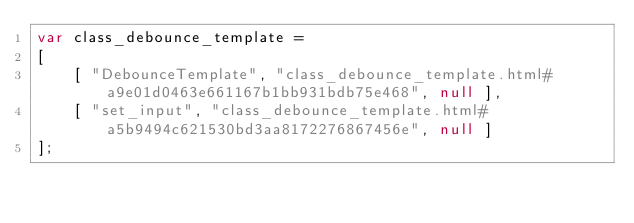Convert code to text. <code><loc_0><loc_0><loc_500><loc_500><_JavaScript_>var class_debounce_template =
[
    [ "DebounceTemplate", "class_debounce_template.html#a9e01d0463e661167b1bb931bdb75e468", null ],
    [ "set_input", "class_debounce_template.html#a5b9494c621530bd3aa8172276867456e", null ]
];</code> 